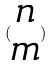Convert formula to latex. <formula><loc_0><loc_0><loc_500><loc_500>( \begin{matrix} n \\ m \end{matrix} )</formula> 